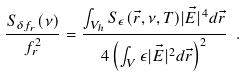Convert formula to latex. <formula><loc_0><loc_0><loc_500><loc_500>\frac { S _ { \delta f _ { r } } ( \nu ) } { f _ { r } ^ { 2 } } = \frac { \int _ { V _ { h } } S _ { \epsilon } ( \vec { r } , \nu , T ) | \vec { E } | ^ { 4 } d \vec { r } } { 4 \left ( \int _ { V } \epsilon | \vec { E } | ^ { 2 } d \vec { r } \right ) ^ { 2 } } \ .</formula> 